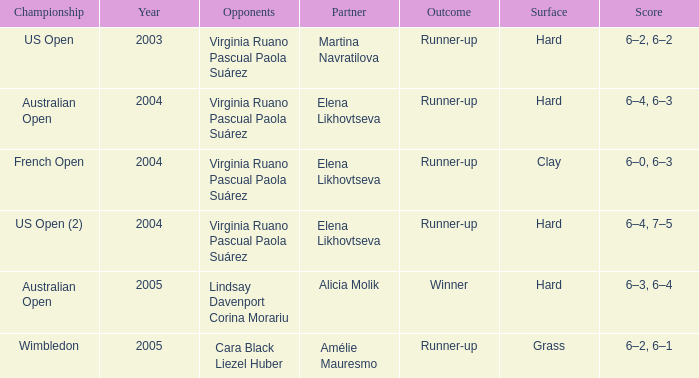When Australian open is the championship what is the lowest year? 2004.0. 